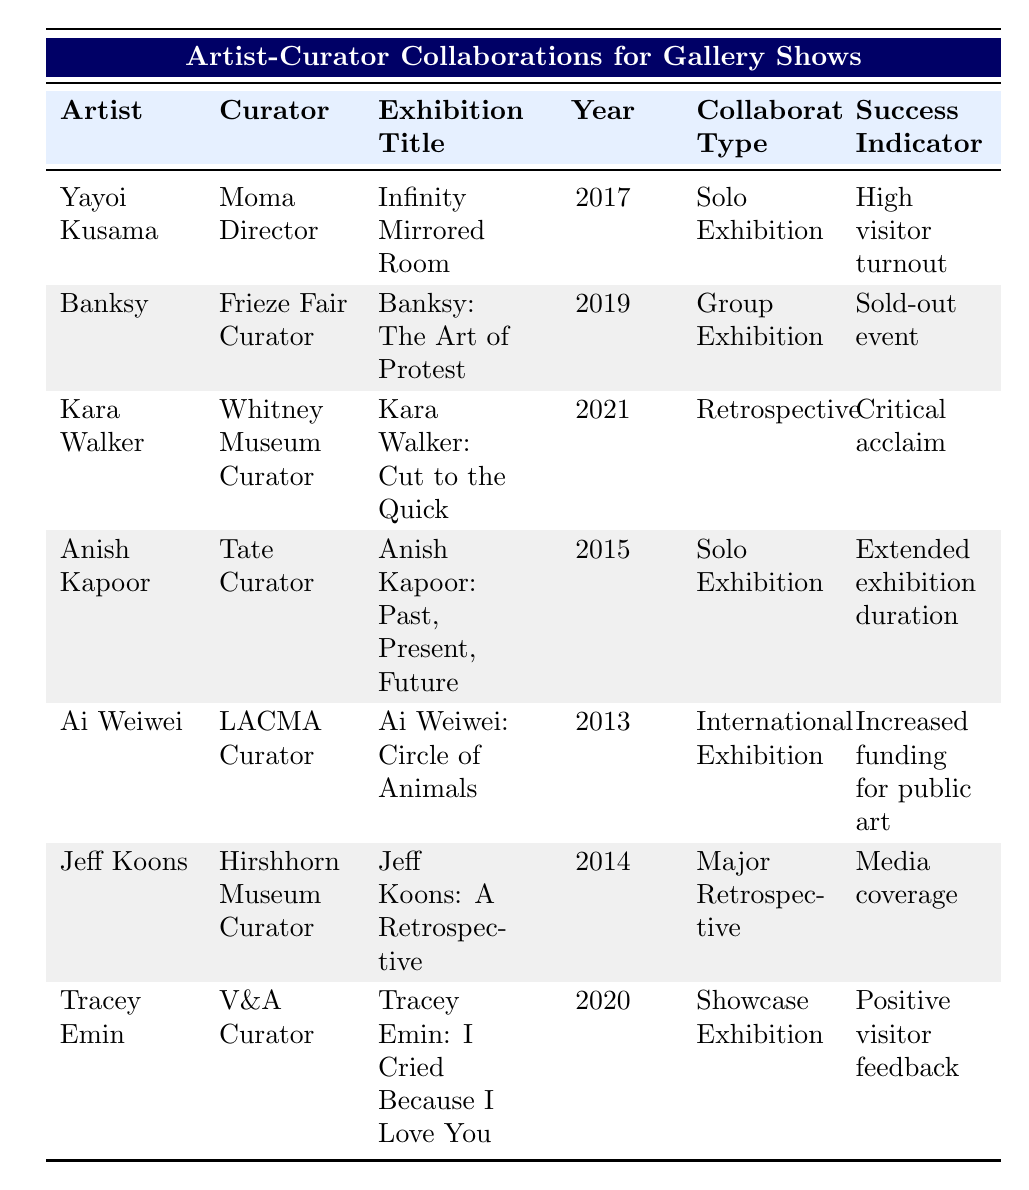What year was "Ai Weiwei: Circle of Animals" exhibited? The table lists "Ai Weiwei: Circle of Animals" under the year column, which shows the exhibition took place in 2013.
Answer: 2013 Who was the curator for "Kara Walker: Cut to the Quick"? The table provides the curator's name next to "Kara Walker: Cut to the Quick," identifying the Whitney Museum Curator as the individual responsible.
Answer: Whitney Museum Curator Is "Infinity Mirrored Room" a group exhibition? Looking at the collaboration type for "Infinity Mirrored Room," it is categorized as a Solo Exhibition, not a group exhibition.
Answer: No Which artist had a sold-out event as a success indicator? The table notes the success indicator for "Banksy: The Art of Protest" was a sold-out event. Thus, by referencing this row, we determine the artist is Banksy.
Answer: Banksy What is the total number of solo exhibitions listed in the table? The table has four entries categorized as Solo Exhibitions. These include Yayoi Kusama and Anish Kapoor. Thus, the total count of solo exhibitions is 2.
Answer: 2 Was the audience engagement for "Tracey Emin: I Cried Because I Love You" focused on workshops and talks? The audience engagement for "Tracey Emin: I Cried Because I Love You" is described as an "Intimate visitor experience," not workshops and talks, indicating a false statement.
Answer: No What medium was used in Banksy's exhibition? The table specifies that Banksy's exhibition "Banksy: The Art of Protest" utilized Street Art as its medium, allowing us to directly identify what medium was featured.
Answer: Street Art Which exhibition had the success indicator of "Increased funding for public art"? Referring to the table, the exhibition "Ai Weiwei: Circle of Animals" had "Increased funding for public art" noted as its success indicator, thus identifying the exhibition.
Answer: Ai Weiwei: Circle of Animals 